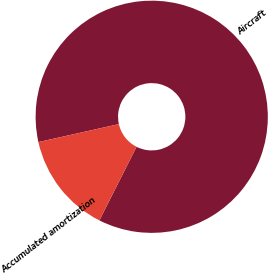Convert chart to OTSL. <chart><loc_0><loc_0><loc_500><loc_500><pie_chart><fcel>Aircraft<fcel>Accumulated amortization<nl><fcel>85.94%<fcel>14.06%<nl></chart> 